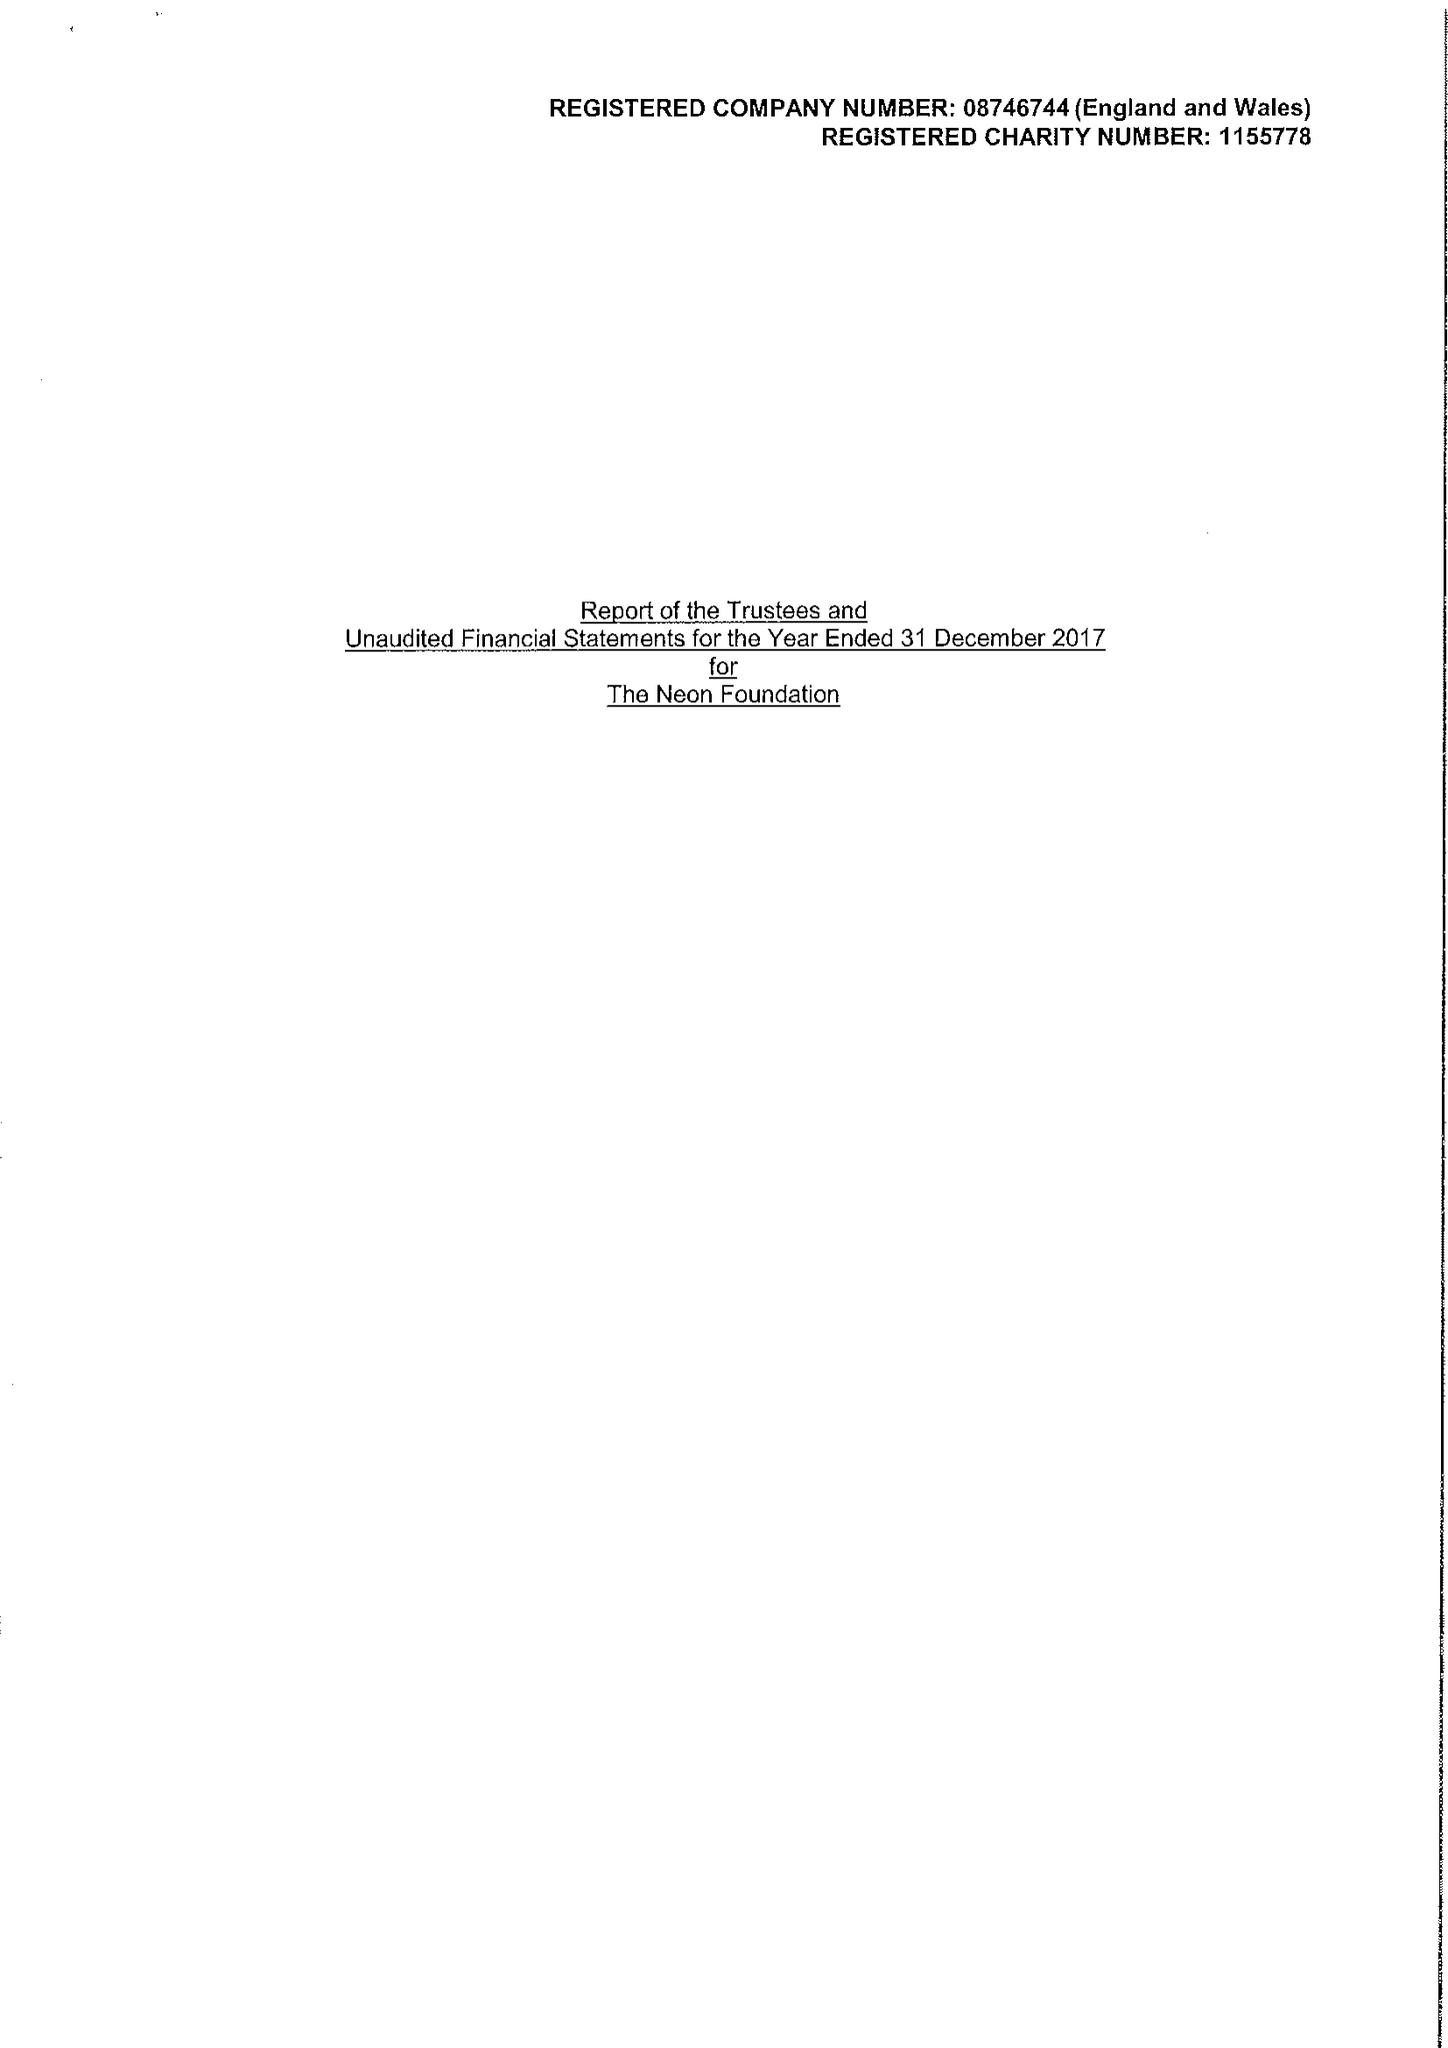What is the value for the charity_number?
Answer the question using a single word or phrase. 1155778 